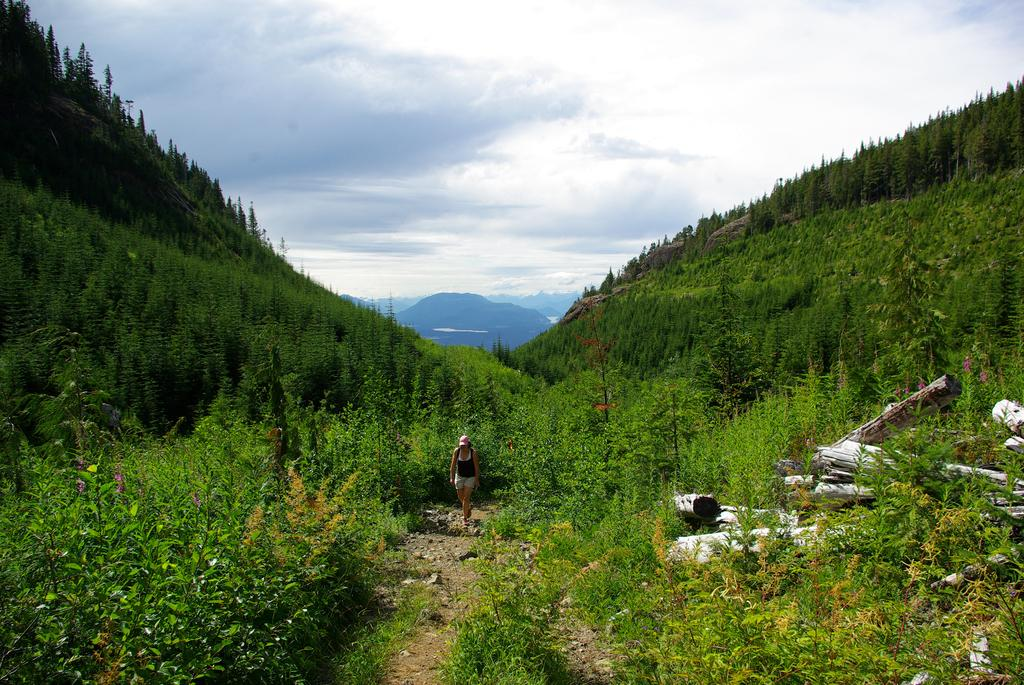What is the person in the image doing? The person is walking in the image. On what surface is the person walking? The person is walking on the ground. What can be seen on either side of the image? There are trees on either side of the image. What type of terrain is visible in the image? There are hills visible in the image. What is visible in the background of the image? The sky is visible in the background of the image. What can be seen in the sky? Clouds are present in the sky. How does the person in the image use the cart? There is no cart present in the image. 